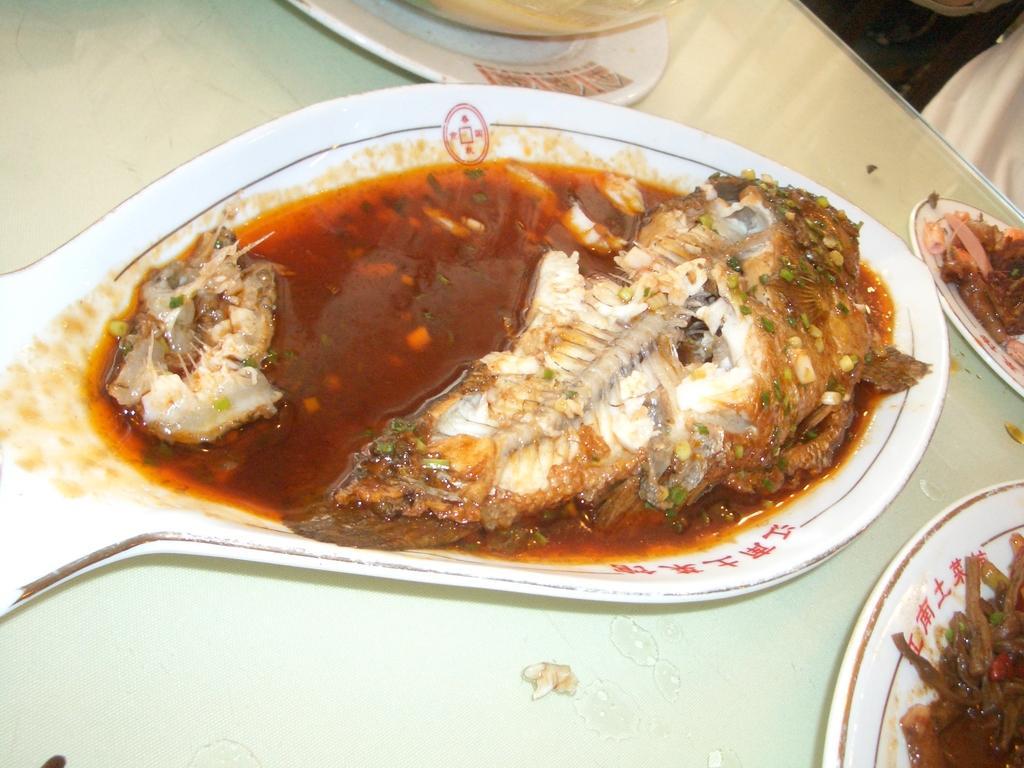How would you summarize this image in a sentence or two? In this picture I can see food items on the plates, on the table. 